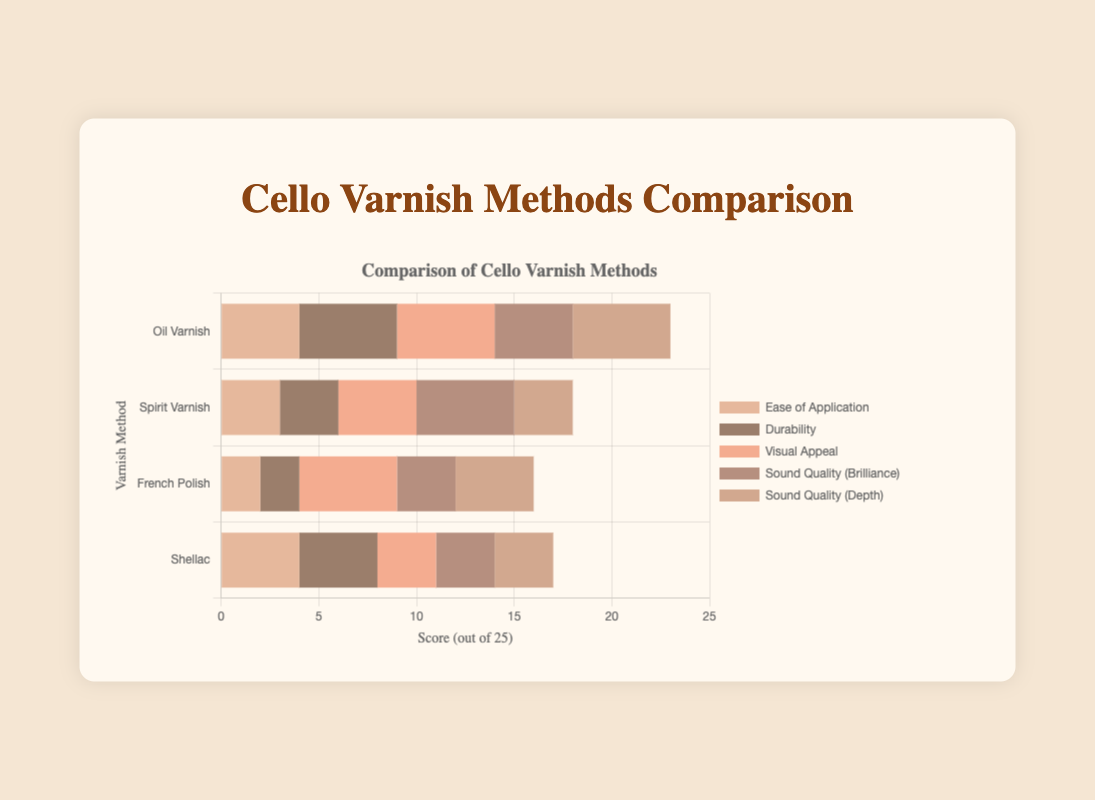Which varnish method has the highest score for sound quality (depth)? The "sound quality (depth)" data indicate that Oil Varnish has the highest score with 5.
Answer: Oil Varnish What is the total score for Oil Varnish across all metrics? Adding the scores for Oil Varnish: 4 (ease of application) + 5 (durability) + 5 (visual appeal) + 4 (sound quality brilliance) + 5 (sound quality depth) = 23.
Answer: 23 Which varnish method is preferred the most by cellists based on usage preference? The tooltip information indicates Oil Varnish has the highest usage preference at 45%, making it the most preferred method.
Answer: Oil Varnish Comparing the ease of application, which varnish method is considered easier to apply: Spirit Varnish or Shellac? The ease of application score for Spirit Varnish is 3, while for Shellac, it's 4. Thus, Shellac is considered easier to apply.
Answer: Shellac Which varnish method balances both visual appeal and durability scores the best? Examining both the visual appeal and durability scores: Oil Varnish (5,5), Spirit Varnish (4,3), French Polish (5,2), and Shellac (3,4). Oil Varnish scores highest in both categories.
Answer: Oil Varnish How does the visual appeal of Spirit Varnish compare to that of French Polish? The visual appeal score for Spirit Varnish is 4 while for French Polish it is 5, so French Polish has a higher visual appeal.
Answer: French Polish Summing the scores for visual appeal and sound quality (brilliance), which varnish method ranks the highest? Oil Varnish: 5+4=9, Spirit Varnish: 4+5=9, French Polish: 5+3=8, Shellac: 3+3=6. Both Oil Varnish and Spirit Varnish score highest with a sum of 9.
Answer: Oil Varnish, Spirit Varnish In terms of sound quality (brilliance), which varnish method is considered the best by cellists? The sound quality (brilliance) score shows Spirit Varnish has the highest value with a score of 5.
Answer: Spirit Varnish For which varnish method is the difference between the durability and ease of application the greatest? The differences are: Oil Varnish (5-4=1), Spirit Varnish (3-3=0), French Polish (2-2=0), Shellac (4-4=0). The greatest difference is found in Oil Varnish with a difference of 1.
Answer: Oil Varnish 